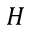Convert formula to latex. <formula><loc_0><loc_0><loc_500><loc_500>H</formula> 